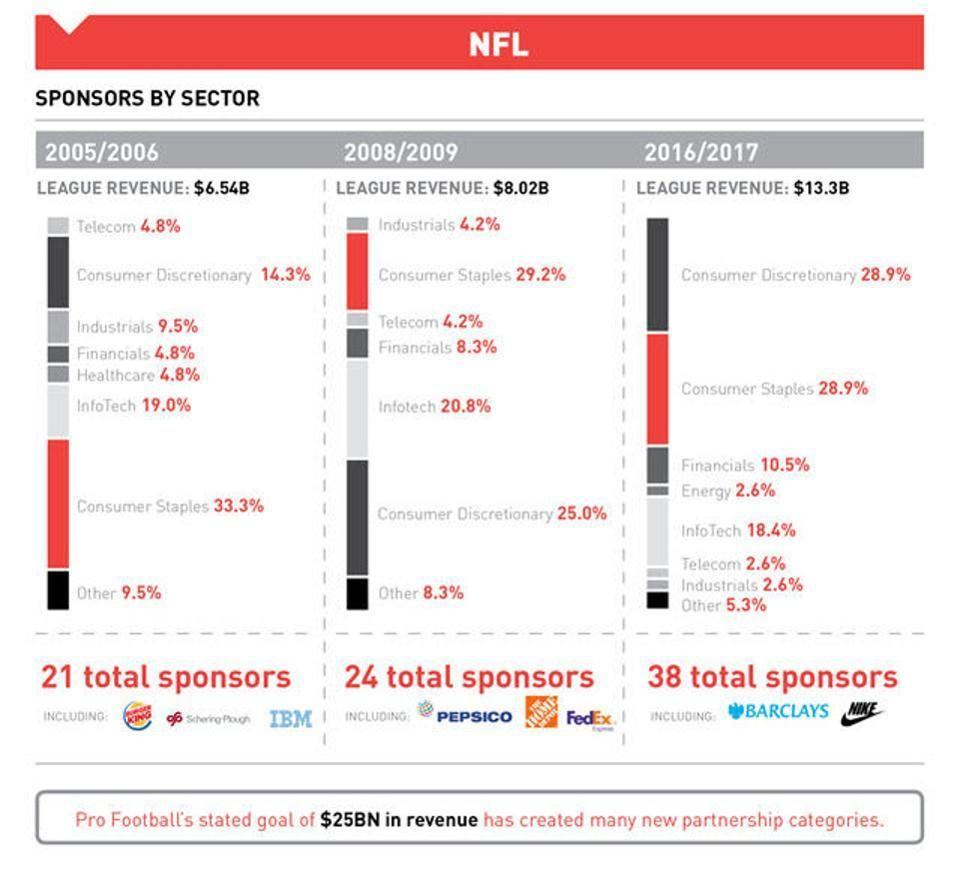During which year was sponsorship from financials sector 10.5%?
Answer the question with a short phrase. 2016/2017 How many total sponsors were there in 2005/2006? 21 PepsiCo is mentioned as a sponsor during which year? 2008/2009 How many total sponsors were there in 2008/2009? 24 What was the percentage of sponsorship by Consumer Staples sector in 2005/2006? 33.3% Barclays was one of the sponsors during which year? 2016/2017 During which year was sponsorship from Infotech sector 20.8%? 2008/2009 